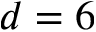<formula> <loc_0><loc_0><loc_500><loc_500>d = 6</formula> 